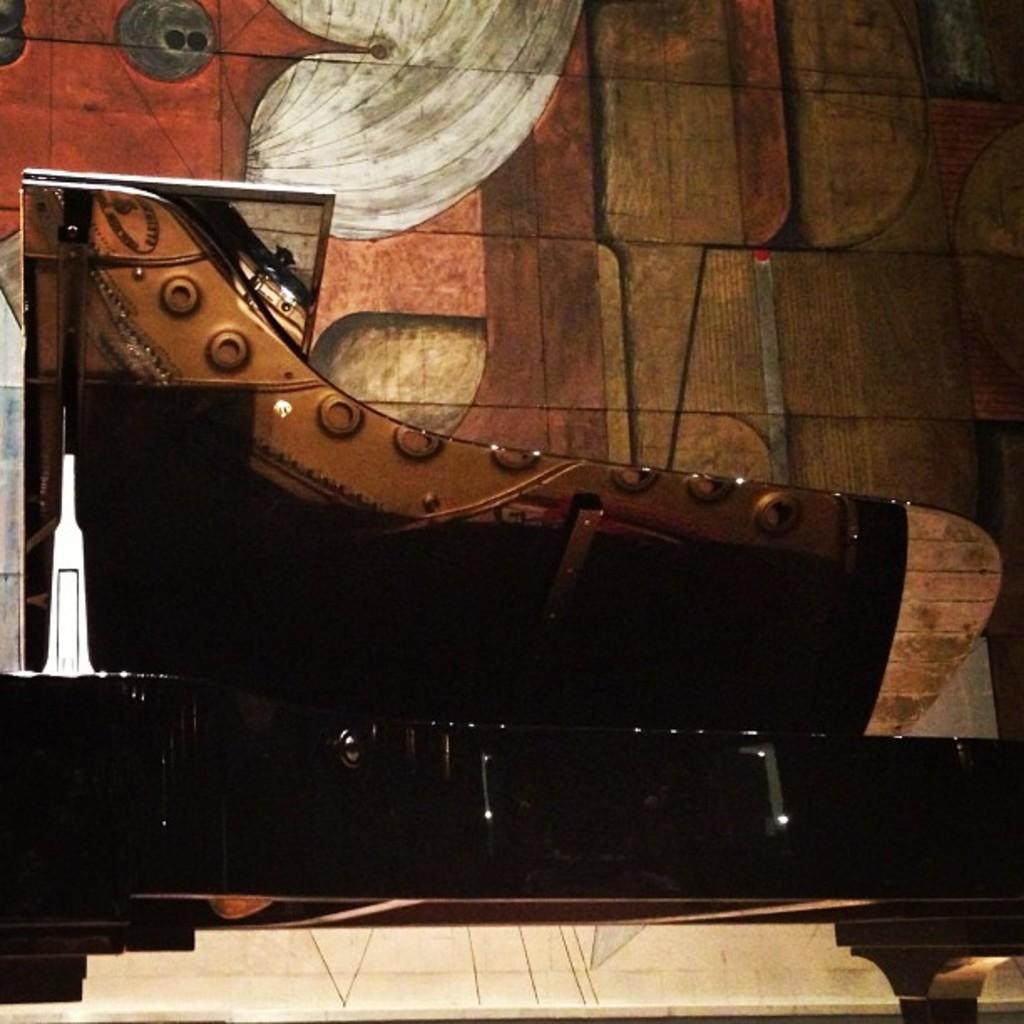In one or two sentences, can you explain what this image depicts? This image is taken inside a room. In this image there is a huge shoe which is made of wood. In the background there is a wall with graffiti on it. This image is looking like a painting. 